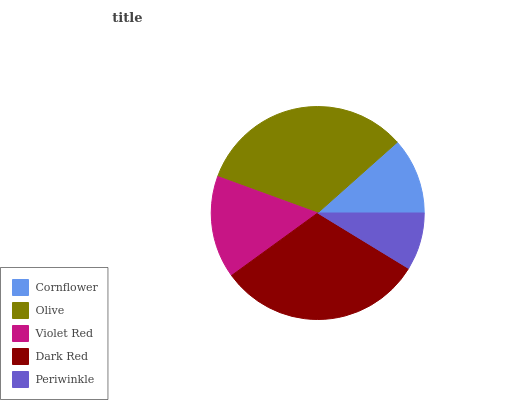Is Periwinkle the minimum?
Answer yes or no. Yes. Is Olive the maximum?
Answer yes or no. Yes. Is Violet Red the minimum?
Answer yes or no. No. Is Violet Red the maximum?
Answer yes or no. No. Is Olive greater than Violet Red?
Answer yes or no. Yes. Is Violet Red less than Olive?
Answer yes or no. Yes. Is Violet Red greater than Olive?
Answer yes or no. No. Is Olive less than Violet Red?
Answer yes or no. No. Is Violet Red the high median?
Answer yes or no. Yes. Is Violet Red the low median?
Answer yes or no. Yes. Is Dark Red the high median?
Answer yes or no. No. Is Periwinkle the low median?
Answer yes or no. No. 